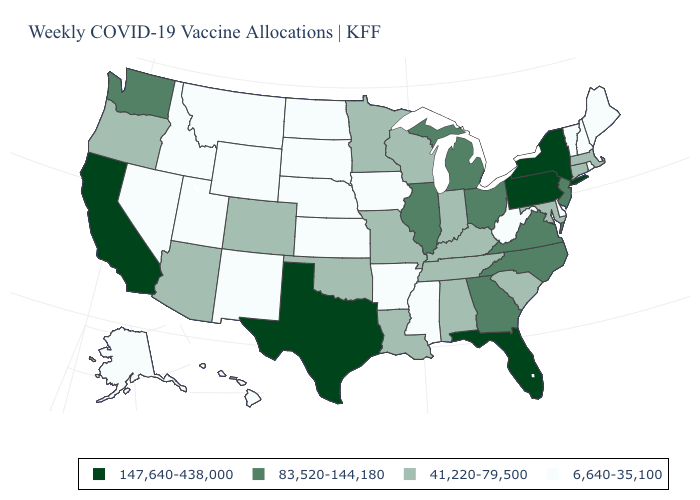Does the map have missing data?
Concise answer only. No. How many symbols are there in the legend?
Concise answer only. 4. What is the highest value in the West ?
Answer briefly. 147,640-438,000. Does New Hampshire have the lowest value in the Northeast?
Short answer required. Yes. Which states have the lowest value in the USA?
Keep it brief. Alaska, Arkansas, Delaware, Hawaii, Idaho, Iowa, Kansas, Maine, Mississippi, Montana, Nebraska, Nevada, New Hampshire, New Mexico, North Dakota, Rhode Island, South Dakota, Utah, Vermont, West Virginia, Wyoming. What is the value of Virginia?
Quick response, please. 83,520-144,180. Name the states that have a value in the range 147,640-438,000?
Concise answer only. California, Florida, New York, Pennsylvania, Texas. What is the value of Illinois?
Quick response, please. 83,520-144,180. Name the states that have a value in the range 6,640-35,100?
Answer briefly. Alaska, Arkansas, Delaware, Hawaii, Idaho, Iowa, Kansas, Maine, Mississippi, Montana, Nebraska, Nevada, New Hampshire, New Mexico, North Dakota, Rhode Island, South Dakota, Utah, Vermont, West Virginia, Wyoming. What is the value of New Hampshire?
Concise answer only. 6,640-35,100. Name the states that have a value in the range 41,220-79,500?
Keep it brief. Alabama, Arizona, Colorado, Connecticut, Indiana, Kentucky, Louisiana, Maryland, Massachusetts, Minnesota, Missouri, Oklahoma, Oregon, South Carolina, Tennessee, Wisconsin. Does Maine have the highest value in the USA?
Write a very short answer. No. Does the first symbol in the legend represent the smallest category?
Short answer required. No. Does California have the lowest value in the USA?
Give a very brief answer. No. 